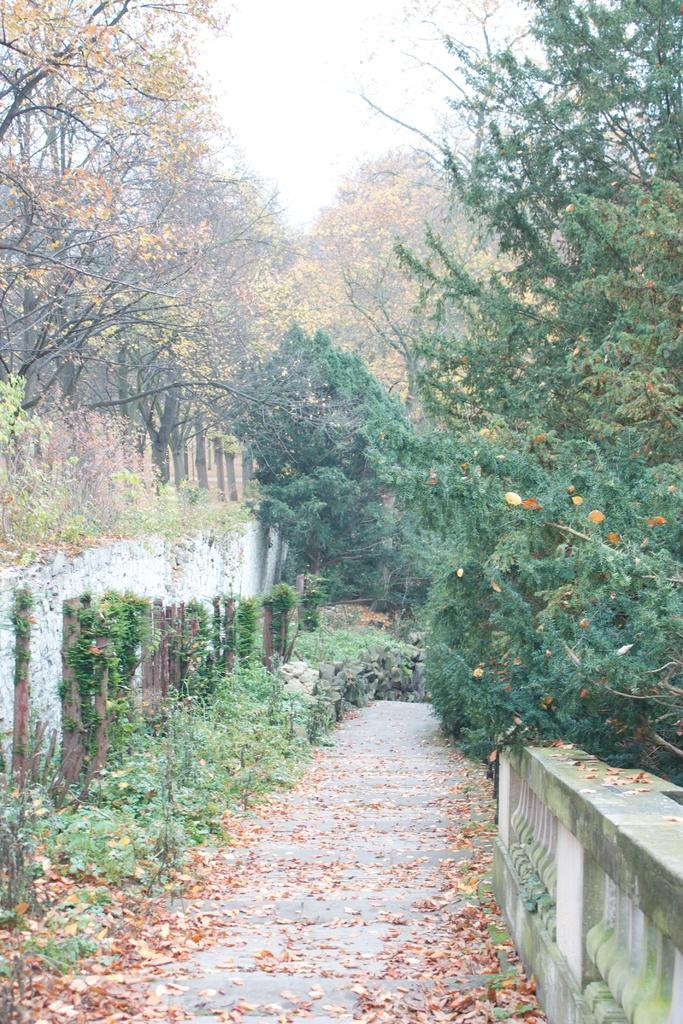What type of surface can be seen in the image? There is a road in the image. What structures are present in the image? There are walls in the image. What type of vegetation is visible in the image? There are plants and trees in the image. What additional detail can be observed on the ground? Dried leaves are present in the image. What can be seen in the background of the image? The sky is visible in the background of the image. What type of note is attached to the tree in the image? There is no note attached to the tree in the image. What kind of trouble can be seen in the image? There is no trouble or problem depicted in the image; it features a road, walls, plants, dried leaves, trees, and the sky. 